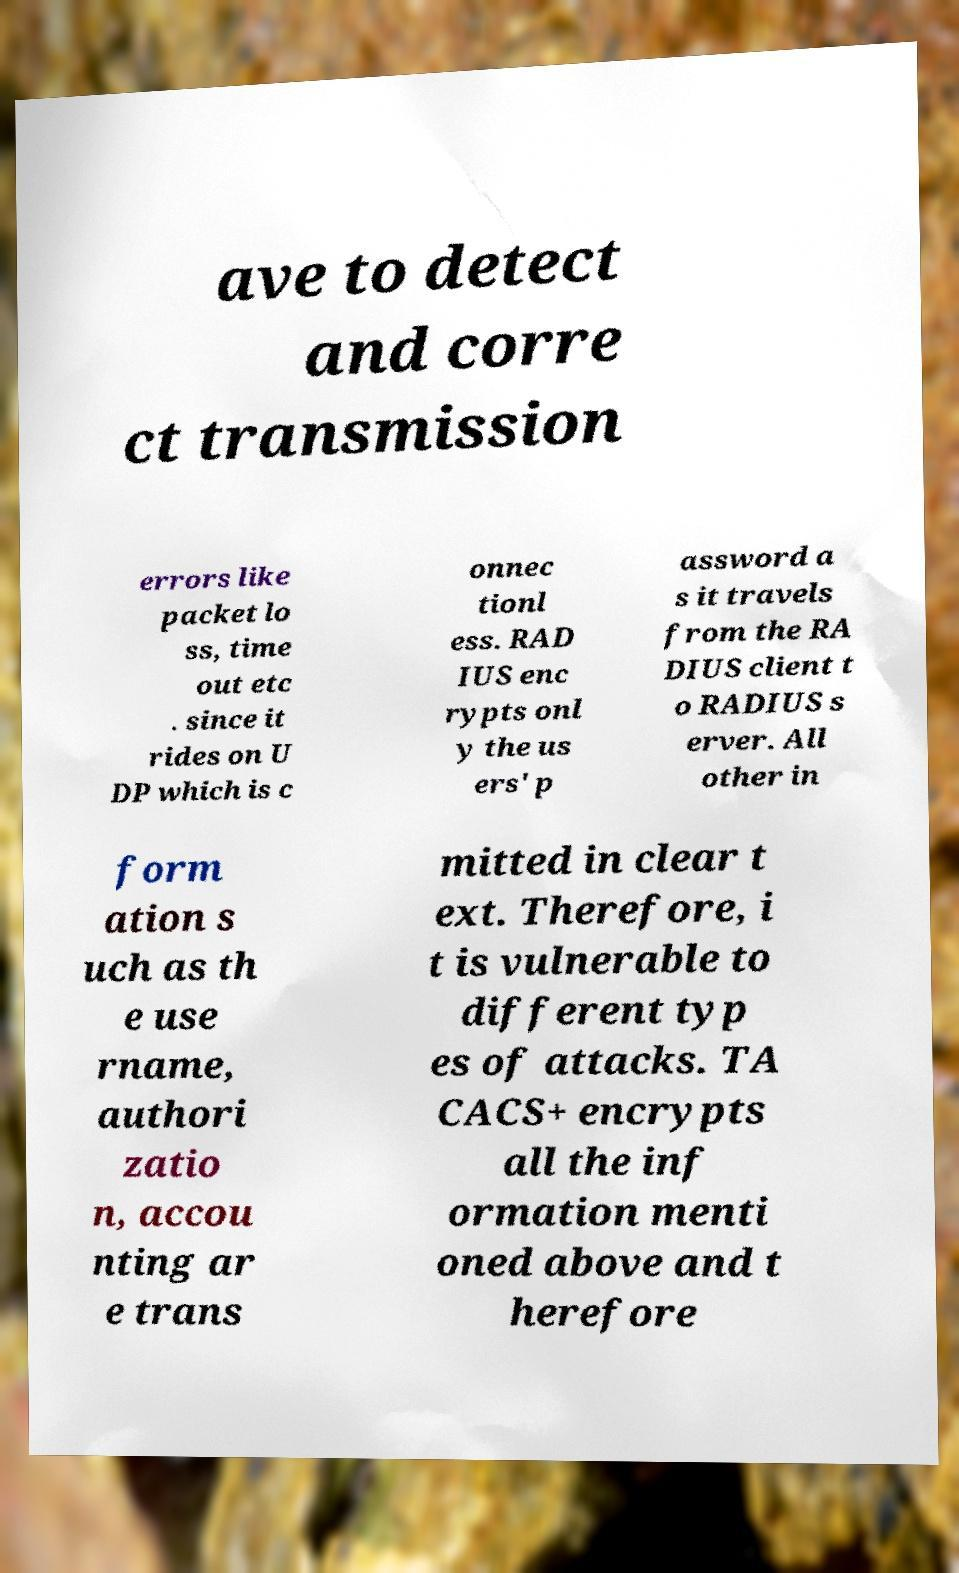Can you accurately transcribe the text from the provided image for me? ave to detect and corre ct transmission errors like packet lo ss, time out etc . since it rides on U DP which is c onnec tionl ess. RAD IUS enc rypts onl y the us ers' p assword a s it travels from the RA DIUS client t o RADIUS s erver. All other in form ation s uch as th e use rname, authori zatio n, accou nting ar e trans mitted in clear t ext. Therefore, i t is vulnerable to different typ es of attacks. TA CACS+ encrypts all the inf ormation menti oned above and t herefore 